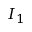Convert formula to latex. <formula><loc_0><loc_0><loc_500><loc_500>I _ { 1 }</formula> 